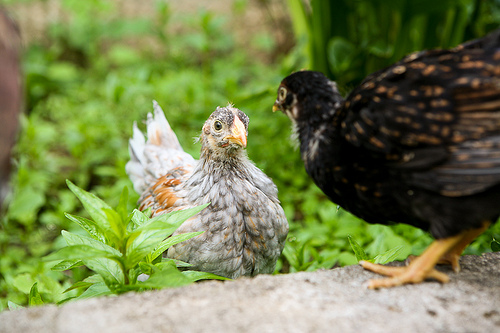<image>
Is there a black bird on the gray bird? No. The black bird is not positioned on the gray bird. They may be near each other, but the black bird is not supported by or resting on top of the gray bird. Is there a plant in front of the hen? Yes. The plant is positioned in front of the hen, appearing closer to the camera viewpoint. 